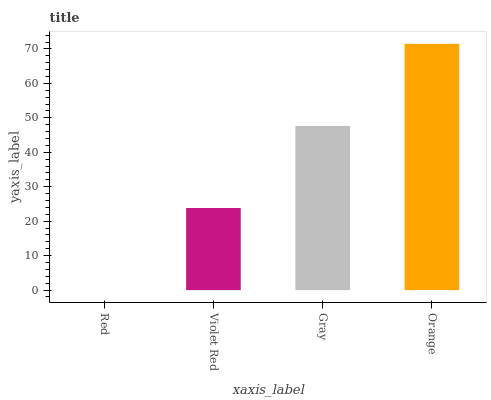Is Violet Red the minimum?
Answer yes or no. No. Is Violet Red the maximum?
Answer yes or no. No. Is Violet Red greater than Red?
Answer yes or no. Yes. Is Red less than Violet Red?
Answer yes or no. Yes. Is Red greater than Violet Red?
Answer yes or no. No. Is Violet Red less than Red?
Answer yes or no. No. Is Gray the high median?
Answer yes or no. Yes. Is Violet Red the low median?
Answer yes or no. Yes. Is Violet Red the high median?
Answer yes or no. No. Is Gray the low median?
Answer yes or no. No. 